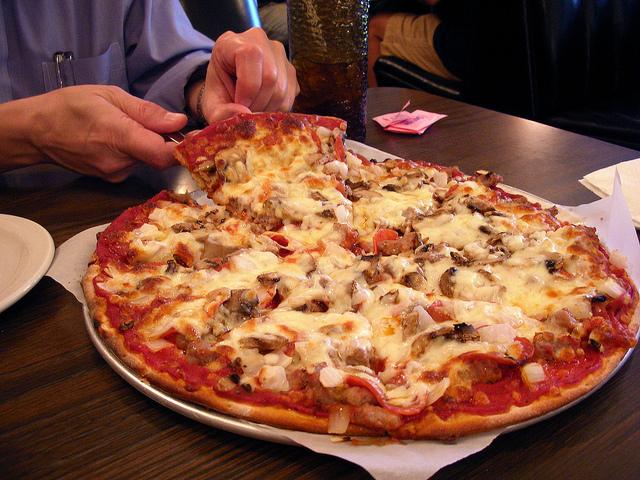What is he eating?
Be succinct. Pizza. What is the person doing?
Write a very short answer. Eating. Does this person have something to drink?
Give a very brief answer. Yes. 